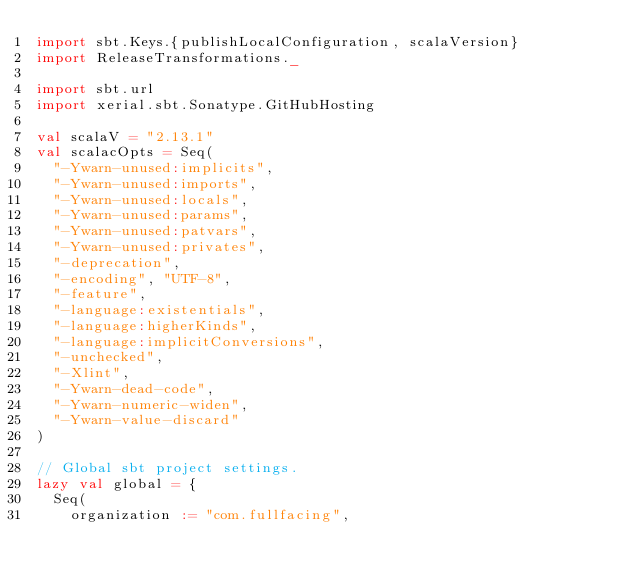<code> <loc_0><loc_0><loc_500><loc_500><_Scala_>import sbt.Keys.{publishLocalConfiguration, scalaVersion}
import ReleaseTransformations._

import sbt.url
import xerial.sbt.Sonatype.GitHubHosting

val scalaV = "2.13.1"
val scalacOpts = Seq(
  "-Ywarn-unused:implicits",
  "-Ywarn-unused:imports",
  "-Ywarn-unused:locals",
  "-Ywarn-unused:params",
  "-Ywarn-unused:patvars",
  "-Ywarn-unused:privates",
  "-deprecation",
  "-encoding", "UTF-8",
  "-feature",
  "-language:existentials",
  "-language:higherKinds",
  "-language:implicitConversions",
  "-unchecked",
  "-Xlint",
  "-Ywarn-dead-code",
  "-Ywarn-numeric-widen",
  "-Ywarn-value-discard"
)

// Global sbt project settings.
lazy val global = {
  Seq(
    organization := "com.fullfacing",</code> 